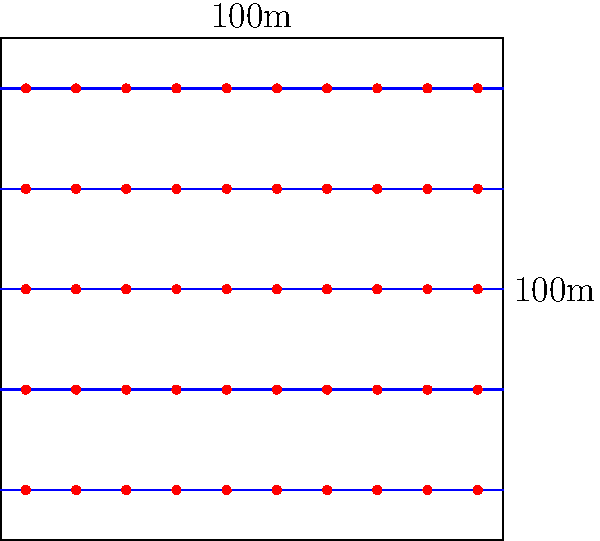Given a square field of 100m x 100m, you want to design an irrigation system with parallel lines spaced 20m apart. If sprinklers are placed every 10m along these lines, what is the total number of sprinklers needed to cover the entire field efficiently? To solve this problem, we'll follow these steps:

1. Calculate the number of irrigation lines:
   - Field width = 100m
   - Spacing between lines = 20m
   - Number of lines = $\frac{100m}{20m} + 1$ (including both edges) = 6 lines

2. Calculate the number of sprinklers per line:
   - Field length = 100m
   - Spacing between sprinklers = 10m
   - Sprinklers per line = $\frac{100m}{10m} + 1$ (including both ends) = 11 sprinklers

3. Calculate the total number of sprinklers:
   - Total sprinklers = Number of lines × Sprinklers per line
   - Total sprinklers = $6 \times 11 = 66$ sprinklers

Therefore, 66 sprinklers are needed to cover the entire field efficiently with this irrigation system layout.
Answer: 66 sprinklers 